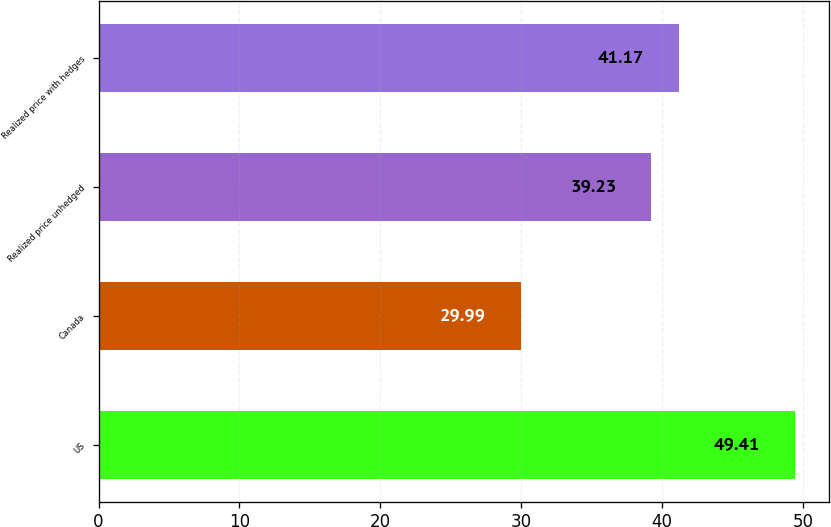Convert chart. <chart><loc_0><loc_0><loc_500><loc_500><bar_chart><fcel>US<fcel>Canada<fcel>Realized price unhedged<fcel>Realized price with hedges<nl><fcel>49.41<fcel>29.99<fcel>39.23<fcel>41.17<nl></chart> 